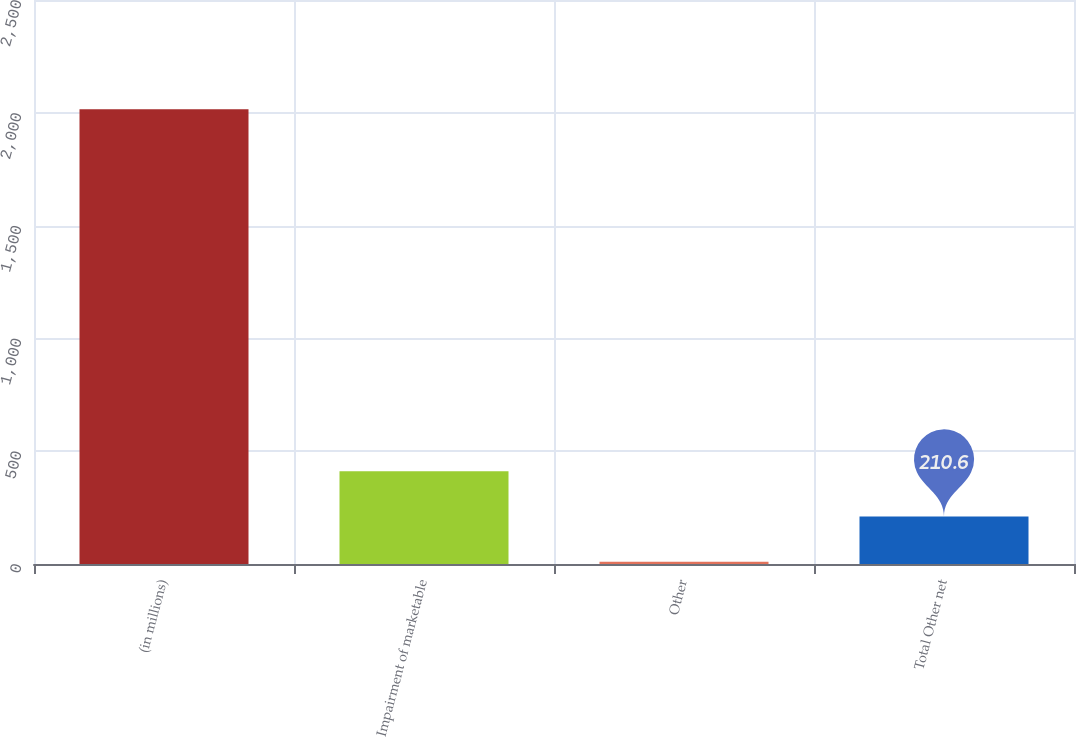<chart> <loc_0><loc_0><loc_500><loc_500><bar_chart><fcel>(in millions)<fcel>Impairment of marketable<fcel>Other<fcel>Total Other net<nl><fcel>2016<fcel>411.2<fcel>10<fcel>210.6<nl></chart> 